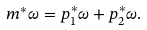Convert formula to latex. <formula><loc_0><loc_0><loc_500><loc_500>m ^ { * } \omega = p _ { 1 } ^ { * } \omega + p _ { 2 } ^ { * } \omega .</formula> 